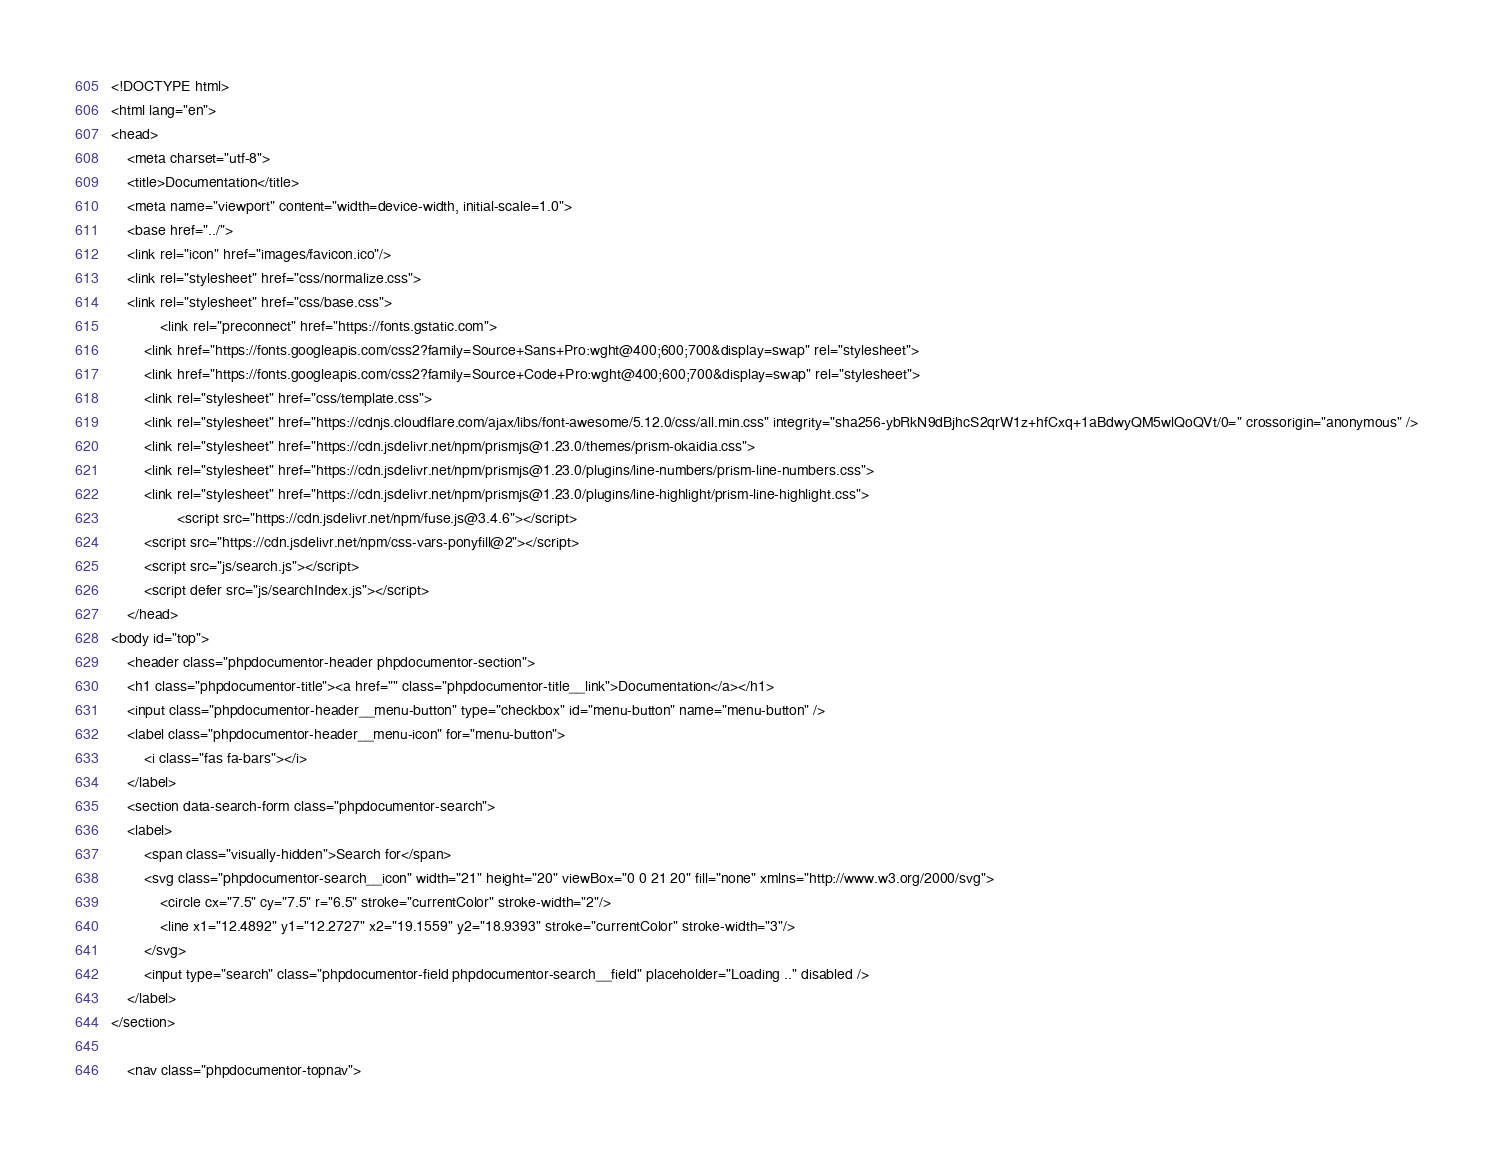Convert code to text. <code><loc_0><loc_0><loc_500><loc_500><_HTML_><!DOCTYPE html>
<html lang="en">
<head>
    <meta charset="utf-8">
    <title>Documentation</title>
    <meta name="viewport" content="width=device-width, initial-scale=1.0">
    <base href="../">
    <link rel="icon" href="images/favicon.ico"/>
    <link rel="stylesheet" href="css/normalize.css">
    <link rel="stylesheet" href="css/base.css">
            <link rel="preconnect" href="https://fonts.gstatic.com">
        <link href="https://fonts.googleapis.com/css2?family=Source+Sans+Pro:wght@400;600;700&display=swap" rel="stylesheet">
        <link href="https://fonts.googleapis.com/css2?family=Source+Code+Pro:wght@400;600;700&display=swap" rel="stylesheet">
        <link rel="stylesheet" href="css/template.css">
        <link rel="stylesheet" href="https://cdnjs.cloudflare.com/ajax/libs/font-awesome/5.12.0/css/all.min.css" integrity="sha256-ybRkN9dBjhcS2qrW1z+hfCxq+1aBdwyQM5wlQoQVt/0=" crossorigin="anonymous" />
        <link rel="stylesheet" href="https://cdn.jsdelivr.net/npm/prismjs@1.23.0/themes/prism-okaidia.css">
        <link rel="stylesheet" href="https://cdn.jsdelivr.net/npm/prismjs@1.23.0/plugins/line-numbers/prism-line-numbers.css">
        <link rel="stylesheet" href="https://cdn.jsdelivr.net/npm/prismjs@1.23.0/plugins/line-highlight/prism-line-highlight.css">
                <script src="https://cdn.jsdelivr.net/npm/fuse.js@3.4.6"></script>
        <script src="https://cdn.jsdelivr.net/npm/css-vars-ponyfill@2"></script>
        <script src="js/search.js"></script>
        <script defer src="js/searchIndex.js"></script>
    </head>
<body id="top">
    <header class="phpdocumentor-header phpdocumentor-section">
    <h1 class="phpdocumentor-title"><a href="" class="phpdocumentor-title__link">Documentation</a></h1>
    <input class="phpdocumentor-header__menu-button" type="checkbox" id="menu-button" name="menu-button" />
    <label class="phpdocumentor-header__menu-icon" for="menu-button">
        <i class="fas fa-bars"></i>
    </label>
    <section data-search-form class="phpdocumentor-search">
    <label>
        <span class="visually-hidden">Search for</span>
        <svg class="phpdocumentor-search__icon" width="21" height="20" viewBox="0 0 21 20" fill="none" xmlns="http://www.w3.org/2000/svg">
            <circle cx="7.5" cy="7.5" r="6.5" stroke="currentColor" stroke-width="2"/>
            <line x1="12.4892" y1="12.2727" x2="19.1559" y2="18.9393" stroke="currentColor" stroke-width="3"/>
        </svg>
        <input type="search" class="phpdocumentor-field phpdocumentor-search__field" placeholder="Loading .." disabled />
    </label>
</section>

    <nav class="phpdocumentor-topnav"></code> 